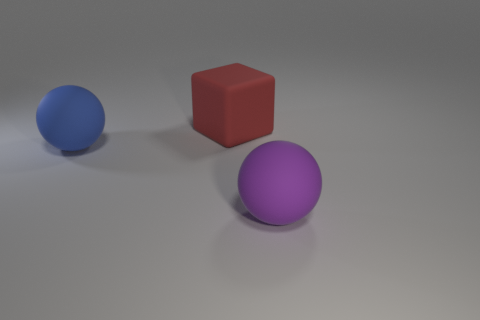How many rubber objects are behind the purple matte object? Behind the purple matte object, there appear to be two objects: a blue sphere and a red cube. Assuming that these objects are rubber based on their appearance and context, there are two rubber objects behind the purple matte object. 